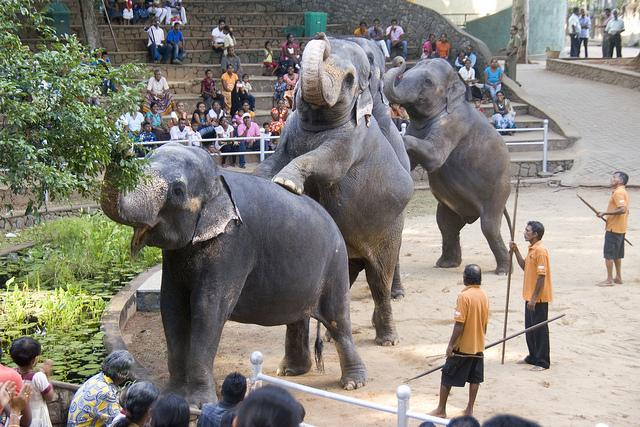What animals might be found in the pond here? Please explain your reasoning. fish. Answer a is a type of animal that is commonly found in a pond and none of the other answers are. 